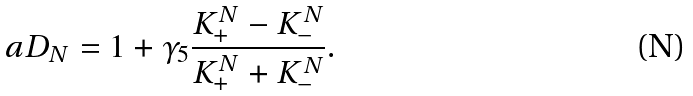<formula> <loc_0><loc_0><loc_500><loc_500>a D _ { N } = 1 + \gamma _ { 5 } \frac { K _ { + } ^ { N } - K _ { - } ^ { N } } { K _ { + } ^ { N } + K _ { - } ^ { N } } .</formula> 